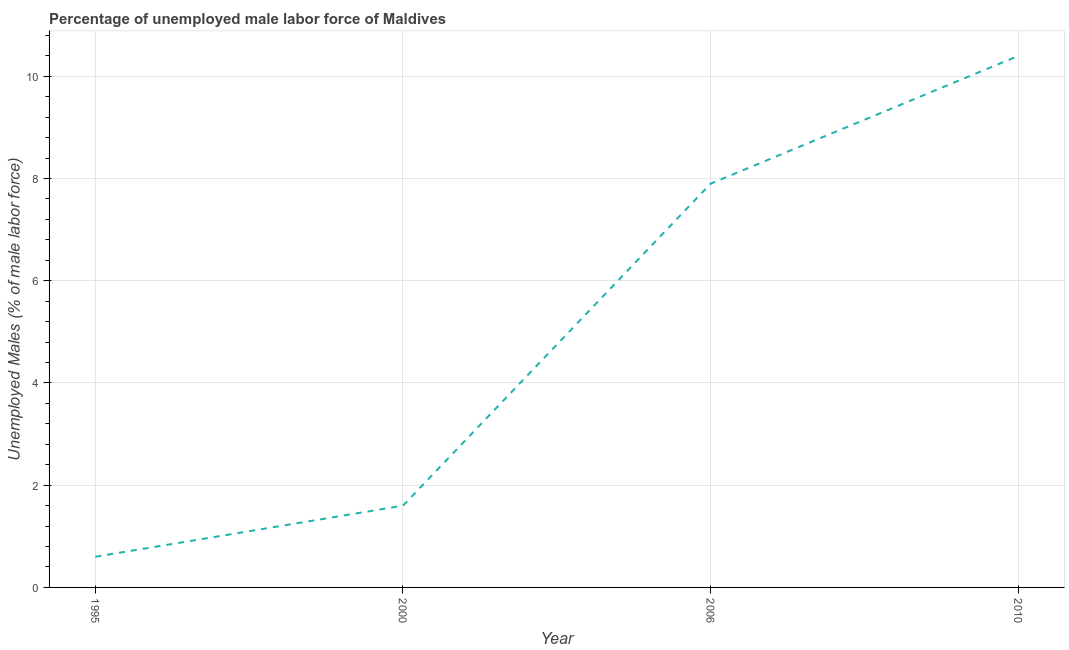What is the total unemployed male labour force in 2006?
Your answer should be compact. 7.9. Across all years, what is the maximum total unemployed male labour force?
Offer a terse response. 10.4. Across all years, what is the minimum total unemployed male labour force?
Your answer should be very brief. 0.6. What is the sum of the total unemployed male labour force?
Keep it short and to the point. 20.5. What is the difference between the total unemployed male labour force in 2000 and 2010?
Offer a very short reply. -8.8. What is the average total unemployed male labour force per year?
Give a very brief answer. 5.12. What is the median total unemployed male labour force?
Provide a short and direct response. 4.75. Do a majority of the years between 1995 and 2000 (inclusive) have total unemployed male labour force greater than 4 %?
Give a very brief answer. No. What is the ratio of the total unemployed male labour force in 1995 to that in 2000?
Offer a very short reply. 0.38. Is the total unemployed male labour force in 2006 less than that in 2010?
Ensure brevity in your answer.  Yes. What is the difference between the highest and the second highest total unemployed male labour force?
Provide a short and direct response. 2.5. Is the sum of the total unemployed male labour force in 1995 and 2000 greater than the maximum total unemployed male labour force across all years?
Provide a short and direct response. No. What is the difference between the highest and the lowest total unemployed male labour force?
Offer a very short reply. 9.8. In how many years, is the total unemployed male labour force greater than the average total unemployed male labour force taken over all years?
Offer a very short reply. 2. Does the total unemployed male labour force monotonically increase over the years?
Your response must be concise. Yes. What is the difference between two consecutive major ticks on the Y-axis?
Your answer should be very brief. 2. What is the title of the graph?
Offer a terse response. Percentage of unemployed male labor force of Maldives. What is the label or title of the Y-axis?
Offer a very short reply. Unemployed Males (% of male labor force). What is the Unemployed Males (% of male labor force) in 1995?
Provide a short and direct response. 0.6. What is the Unemployed Males (% of male labor force) in 2000?
Give a very brief answer. 1.6. What is the Unemployed Males (% of male labor force) in 2006?
Ensure brevity in your answer.  7.9. What is the Unemployed Males (% of male labor force) of 2010?
Your answer should be very brief. 10.4. What is the ratio of the Unemployed Males (% of male labor force) in 1995 to that in 2006?
Offer a terse response. 0.08. What is the ratio of the Unemployed Males (% of male labor force) in 1995 to that in 2010?
Your response must be concise. 0.06. What is the ratio of the Unemployed Males (% of male labor force) in 2000 to that in 2006?
Ensure brevity in your answer.  0.2. What is the ratio of the Unemployed Males (% of male labor force) in 2000 to that in 2010?
Offer a very short reply. 0.15. What is the ratio of the Unemployed Males (% of male labor force) in 2006 to that in 2010?
Your response must be concise. 0.76. 